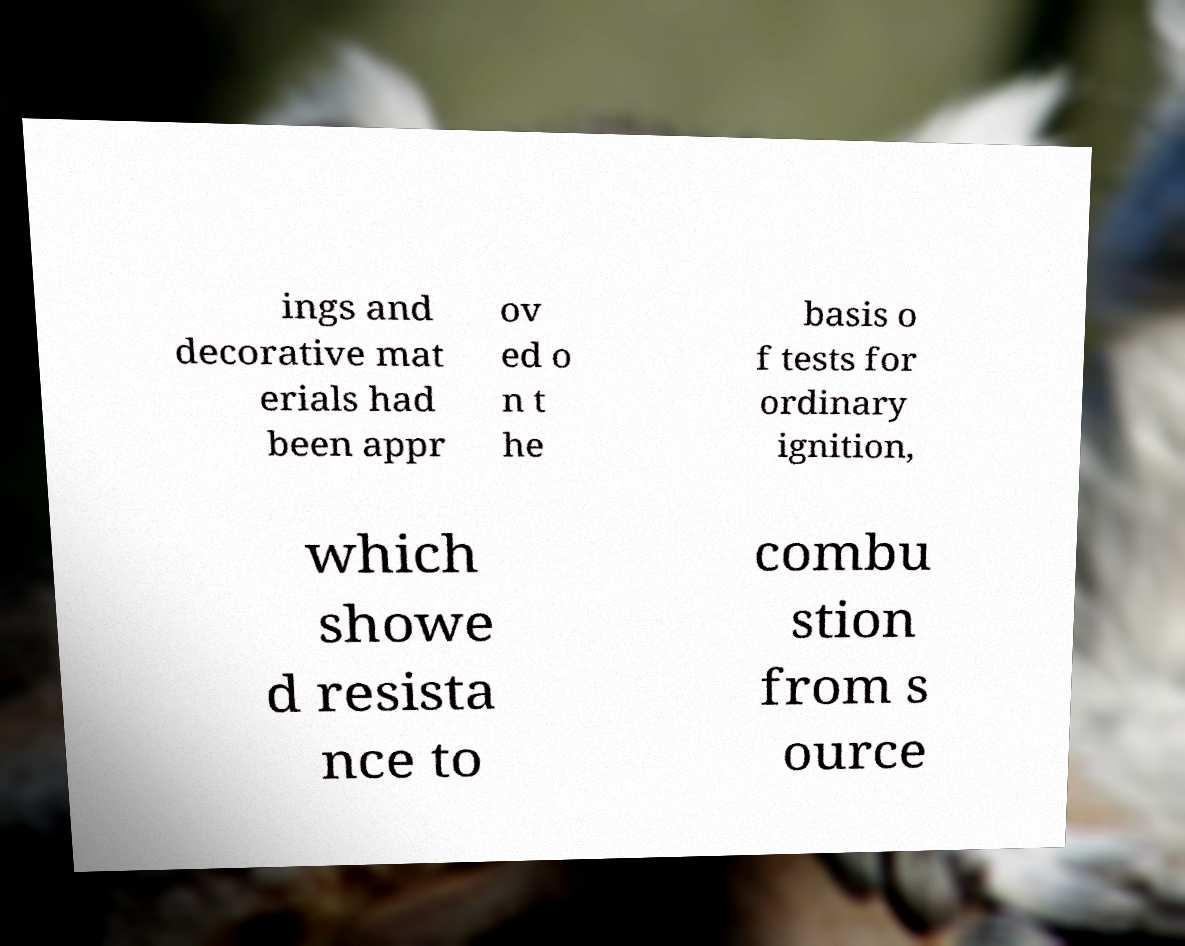Please read and relay the text visible in this image. What does it say? ings and decorative mat erials had been appr ov ed o n t he basis o f tests for ordinary ignition, which showe d resista nce to combu stion from s ource 